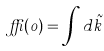<formula> <loc_0><loc_0><loc_500><loc_500>\delta ( 0 ) = \int d \tilde { k }</formula> 